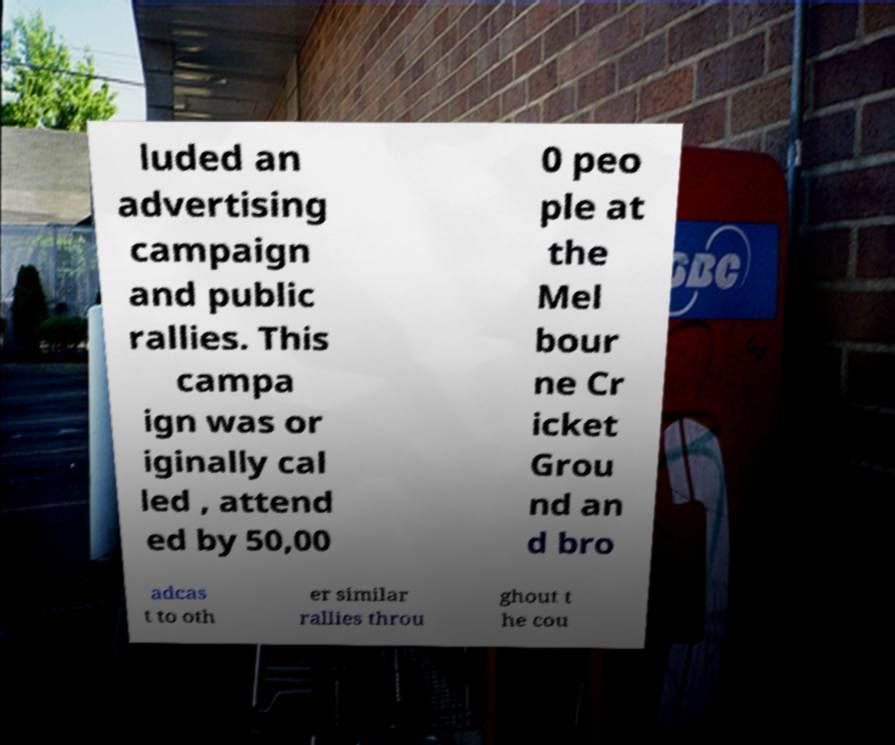There's text embedded in this image that I need extracted. Can you transcribe it verbatim? luded an advertising campaign and public rallies. This campa ign was or iginally cal led , attend ed by 50,00 0 peo ple at the Mel bour ne Cr icket Grou nd an d bro adcas t to oth er similar rallies throu ghout t he cou 